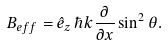Convert formula to latex. <formula><loc_0><loc_0><loc_500><loc_500>B _ { e f f } = \hat { e } _ { z } \, \hbar { k } \frac { \partial } { \partial x } \sin ^ { 2 } \theta .</formula> 